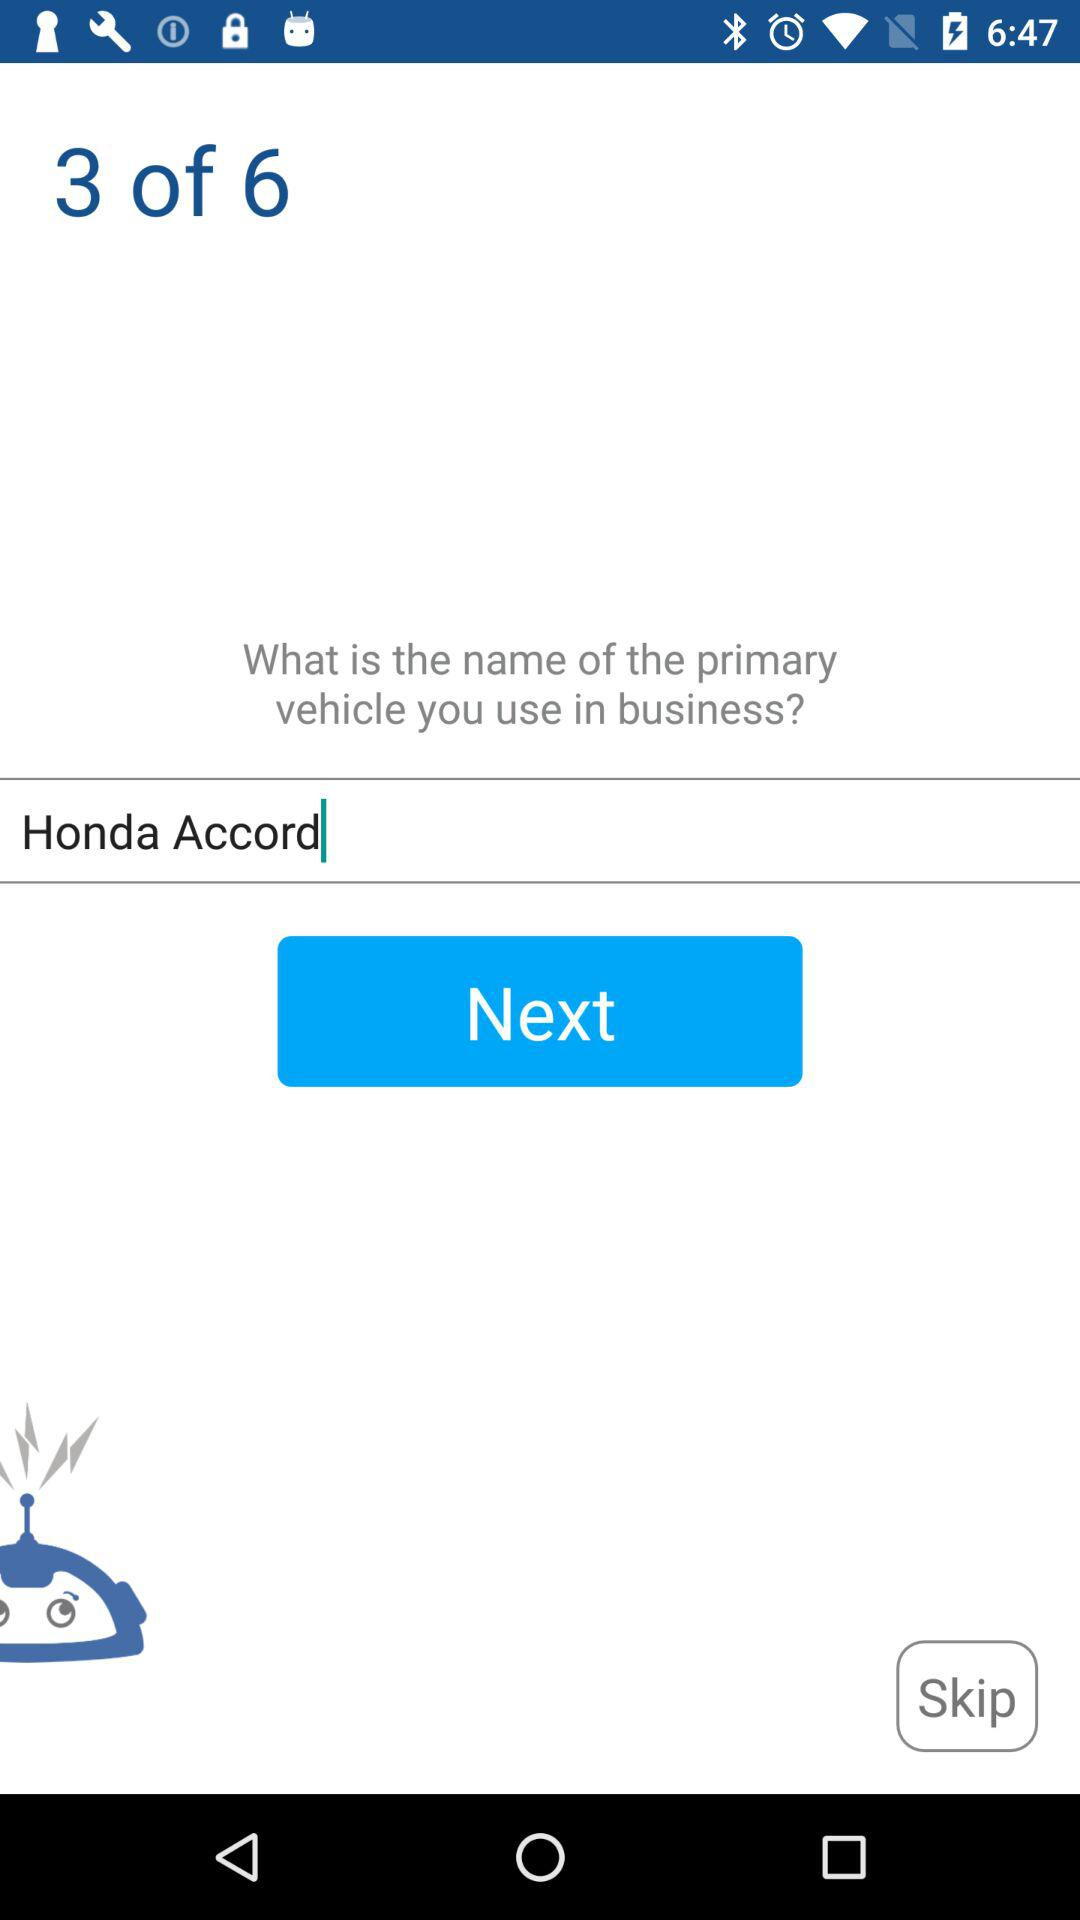What is the name of the vehicle to use in business? The name of the vehicle is "Honda Accord". 